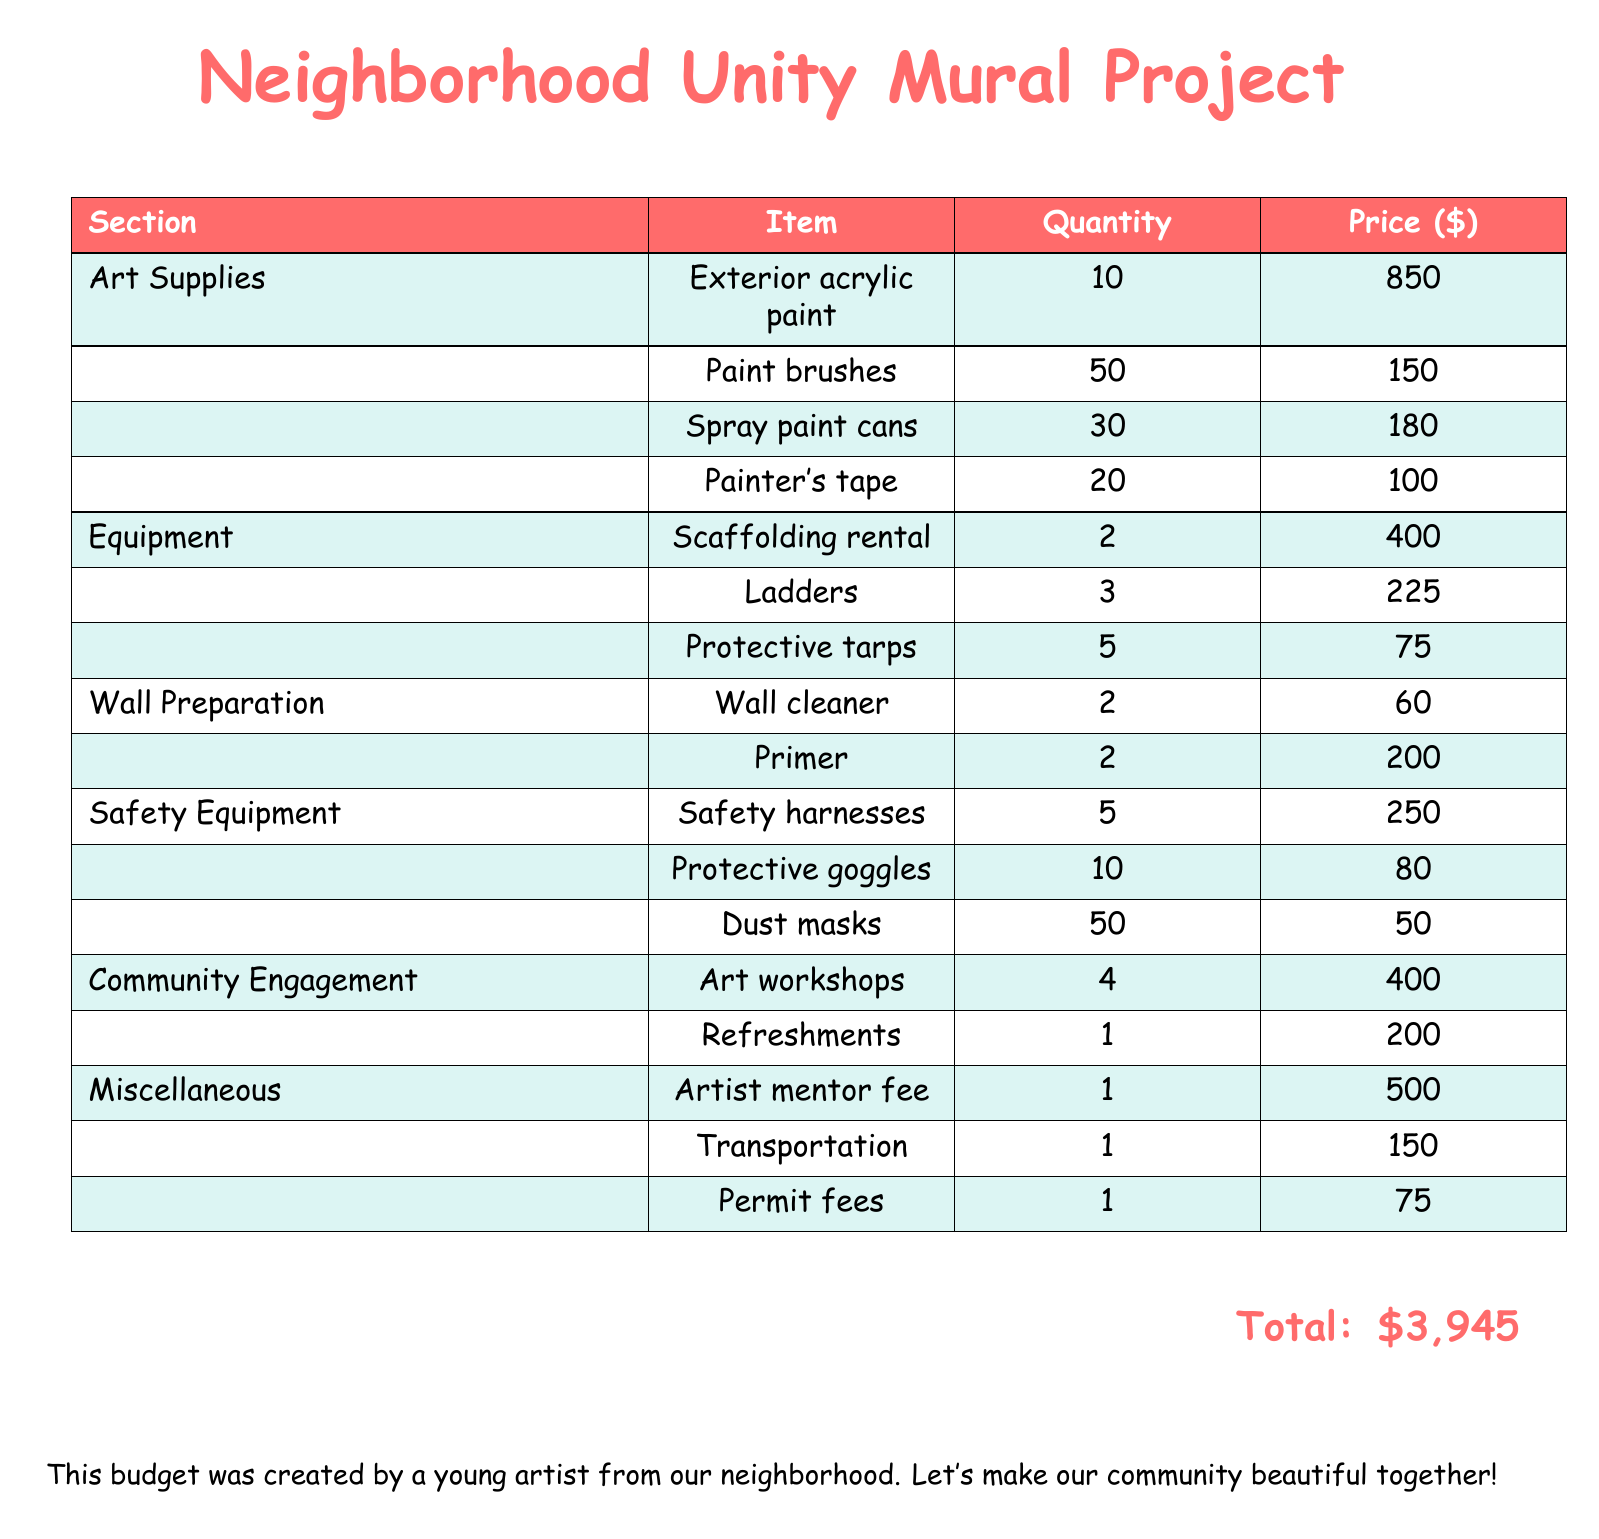what is the total budget for the project? The total budget is listed at the bottom of the document, which sums up all the costs.
Answer: $3,945 how many paint brushes are needed? The number of paint brushes required for the project is specified in the Art Supplies section.
Answer: 50 what is the price of the exterior acrylic paint? The price for the exterior acrylic paint is mentioned in the Art Supplies section.
Answer: $850 how many art workshops are planned? The document indicates the quantity of art workshops under the Community Engagement section.
Answer: 4 what is the cost of the safety harnesses? The price of safety harnesses is found in the Safety Equipment section of the budget.
Answer: $250 how much is allocated for refreshments? The amount set aside for refreshments is stated in the Community Engagement section.
Answer: $200 how many ladders are included in the project budget? The number of ladders mentioned in the Equipment section reveals this information.
Answer: 3 what item is listed under Miscellaneous with a fee of $500? The document specifies the artist mentor fee in the Miscellaneous section.
Answer: Artist mentor fee 